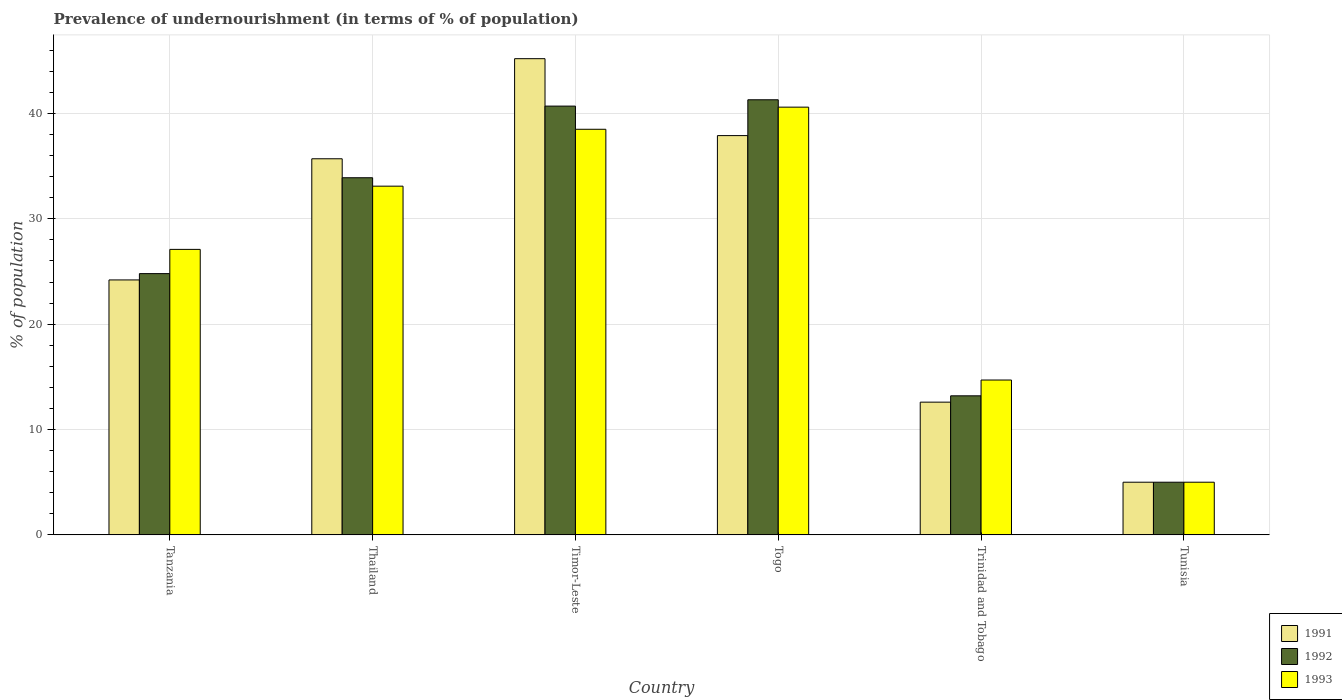How many groups of bars are there?
Make the answer very short. 6. What is the label of the 1st group of bars from the left?
Your response must be concise. Tanzania. What is the percentage of undernourished population in 1992 in Togo?
Offer a terse response. 41.3. Across all countries, what is the maximum percentage of undernourished population in 1993?
Your response must be concise. 40.6. Across all countries, what is the minimum percentage of undernourished population in 1991?
Provide a succinct answer. 5. In which country was the percentage of undernourished population in 1991 maximum?
Provide a succinct answer. Timor-Leste. In which country was the percentage of undernourished population in 1991 minimum?
Keep it short and to the point. Tunisia. What is the total percentage of undernourished population in 1993 in the graph?
Your answer should be compact. 159. What is the difference between the percentage of undernourished population in 1993 in Tanzania and that in Trinidad and Tobago?
Your response must be concise. 12.4. What is the average percentage of undernourished population in 1991 per country?
Keep it short and to the point. 26.77. In how many countries, is the percentage of undernourished population in 1991 greater than 38 %?
Make the answer very short. 1. What is the ratio of the percentage of undernourished population in 1991 in Thailand to that in Togo?
Your response must be concise. 0.94. Is the difference between the percentage of undernourished population in 1991 in Thailand and Togo greater than the difference between the percentage of undernourished population in 1992 in Thailand and Togo?
Offer a terse response. Yes. What is the difference between the highest and the lowest percentage of undernourished population in 1993?
Keep it short and to the point. 35.6. Is the sum of the percentage of undernourished population in 1992 in Tanzania and Thailand greater than the maximum percentage of undernourished population in 1991 across all countries?
Give a very brief answer. Yes. What does the 1st bar from the left in Tanzania represents?
Your answer should be compact. 1991. What does the 3rd bar from the right in Thailand represents?
Keep it short and to the point. 1991. Is it the case that in every country, the sum of the percentage of undernourished population in 1992 and percentage of undernourished population in 1991 is greater than the percentage of undernourished population in 1993?
Ensure brevity in your answer.  Yes. What is the difference between two consecutive major ticks on the Y-axis?
Provide a succinct answer. 10. Are the values on the major ticks of Y-axis written in scientific E-notation?
Your answer should be compact. No. Does the graph contain any zero values?
Offer a terse response. No. Where does the legend appear in the graph?
Your response must be concise. Bottom right. How many legend labels are there?
Keep it short and to the point. 3. How are the legend labels stacked?
Give a very brief answer. Vertical. What is the title of the graph?
Your answer should be compact. Prevalence of undernourishment (in terms of % of population). What is the label or title of the X-axis?
Your response must be concise. Country. What is the label or title of the Y-axis?
Your answer should be compact. % of population. What is the % of population in 1991 in Tanzania?
Ensure brevity in your answer.  24.2. What is the % of population in 1992 in Tanzania?
Ensure brevity in your answer.  24.8. What is the % of population of 1993 in Tanzania?
Provide a succinct answer. 27.1. What is the % of population of 1991 in Thailand?
Offer a terse response. 35.7. What is the % of population in 1992 in Thailand?
Provide a short and direct response. 33.9. What is the % of population in 1993 in Thailand?
Ensure brevity in your answer.  33.1. What is the % of population in 1991 in Timor-Leste?
Offer a terse response. 45.2. What is the % of population in 1992 in Timor-Leste?
Provide a short and direct response. 40.7. What is the % of population of 1993 in Timor-Leste?
Your answer should be very brief. 38.5. What is the % of population in 1991 in Togo?
Your answer should be very brief. 37.9. What is the % of population of 1992 in Togo?
Make the answer very short. 41.3. What is the % of population in 1993 in Togo?
Offer a terse response. 40.6. What is the % of population in 1993 in Trinidad and Tobago?
Offer a very short reply. 14.7. What is the % of population of 1993 in Tunisia?
Your response must be concise. 5. Across all countries, what is the maximum % of population in 1991?
Provide a succinct answer. 45.2. Across all countries, what is the maximum % of population in 1992?
Provide a succinct answer. 41.3. Across all countries, what is the maximum % of population of 1993?
Make the answer very short. 40.6. Across all countries, what is the minimum % of population in 1992?
Offer a very short reply. 5. What is the total % of population in 1991 in the graph?
Your answer should be compact. 160.6. What is the total % of population in 1992 in the graph?
Offer a terse response. 158.9. What is the total % of population in 1993 in the graph?
Your answer should be compact. 159. What is the difference between the % of population of 1991 in Tanzania and that in Thailand?
Your answer should be very brief. -11.5. What is the difference between the % of population of 1992 in Tanzania and that in Timor-Leste?
Provide a short and direct response. -15.9. What is the difference between the % of population of 1993 in Tanzania and that in Timor-Leste?
Give a very brief answer. -11.4. What is the difference between the % of population of 1991 in Tanzania and that in Togo?
Your answer should be compact. -13.7. What is the difference between the % of population in 1992 in Tanzania and that in Togo?
Your response must be concise. -16.5. What is the difference between the % of population in 1993 in Tanzania and that in Trinidad and Tobago?
Your response must be concise. 12.4. What is the difference between the % of population in 1991 in Tanzania and that in Tunisia?
Ensure brevity in your answer.  19.2. What is the difference between the % of population of 1992 in Tanzania and that in Tunisia?
Provide a succinct answer. 19.8. What is the difference between the % of population of 1993 in Tanzania and that in Tunisia?
Offer a very short reply. 22.1. What is the difference between the % of population of 1993 in Thailand and that in Timor-Leste?
Give a very brief answer. -5.4. What is the difference between the % of population of 1991 in Thailand and that in Togo?
Your response must be concise. -2.2. What is the difference between the % of population of 1991 in Thailand and that in Trinidad and Tobago?
Give a very brief answer. 23.1. What is the difference between the % of population in 1992 in Thailand and that in Trinidad and Tobago?
Provide a short and direct response. 20.7. What is the difference between the % of population of 1991 in Thailand and that in Tunisia?
Your answer should be very brief. 30.7. What is the difference between the % of population of 1992 in Thailand and that in Tunisia?
Keep it short and to the point. 28.9. What is the difference between the % of population in 1993 in Thailand and that in Tunisia?
Your answer should be very brief. 28.1. What is the difference between the % of population of 1991 in Timor-Leste and that in Togo?
Make the answer very short. 7.3. What is the difference between the % of population of 1992 in Timor-Leste and that in Togo?
Your answer should be very brief. -0.6. What is the difference between the % of population of 1993 in Timor-Leste and that in Togo?
Make the answer very short. -2.1. What is the difference between the % of population of 1991 in Timor-Leste and that in Trinidad and Tobago?
Ensure brevity in your answer.  32.6. What is the difference between the % of population in 1993 in Timor-Leste and that in Trinidad and Tobago?
Ensure brevity in your answer.  23.8. What is the difference between the % of population of 1991 in Timor-Leste and that in Tunisia?
Your response must be concise. 40.2. What is the difference between the % of population in 1992 in Timor-Leste and that in Tunisia?
Provide a short and direct response. 35.7. What is the difference between the % of population of 1993 in Timor-Leste and that in Tunisia?
Provide a succinct answer. 33.5. What is the difference between the % of population of 1991 in Togo and that in Trinidad and Tobago?
Your answer should be compact. 25.3. What is the difference between the % of population of 1992 in Togo and that in Trinidad and Tobago?
Give a very brief answer. 28.1. What is the difference between the % of population in 1993 in Togo and that in Trinidad and Tobago?
Your answer should be compact. 25.9. What is the difference between the % of population in 1991 in Togo and that in Tunisia?
Offer a terse response. 32.9. What is the difference between the % of population in 1992 in Togo and that in Tunisia?
Offer a terse response. 36.3. What is the difference between the % of population of 1993 in Togo and that in Tunisia?
Your response must be concise. 35.6. What is the difference between the % of population of 1991 in Trinidad and Tobago and that in Tunisia?
Your answer should be very brief. 7.6. What is the difference between the % of population of 1992 in Trinidad and Tobago and that in Tunisia?
Give a very brief answer. 8.2. What is the difference between the % of population of 1993 in Trinidad and Tobago and that in Tunisia?
Make the answer very short. 9.7. What is the difference between the % of population in 1991 in Tanzania and the % of population in 1992 in Timor-Leste?
Your response must be concise. -16.5. What is the difference between the % of population in 1991 in Tanzania and the % of population in 1993 in Timor-Leste?
Your response must be concise. -14.3. What is the difference between the % of population of 1992 in Tanzania and the % of population of 1993 in Timor-Leste?
Offer a very short reply. -13.7. What is the difference between the % of population of 1991 in Tanzania and the % of population of 1992 in Togo?
Make the answer very short. -17.1. What is the difference between the % of population in 1991 in Tanzania and the % of population in 1993 in Togo?
Give a very brief answer. -16.4. What is the difference between the % of population in 1992 in Tanzania and the % of population in 1993 in Togo?
Offer a terse response. -15.8. What is the difference between the % of population in 1991 in Tanzania and the % of population in 1992 in Trinidad and Tobago?
Offer a very short reply. 11. What is the difference between the % of population of 1992 in Tanzania and the % of population of 1993 in Trinidad and Tobago?
Your answer should be very brief. 10.1. What is the difference between the % of population in 1991 in Tanzania and the % of population in 1993 in Tunisia?
Make the answer very short. 19.2. What is the difference between the % of population in 1992 in Tanzania and the % of population in 1993 in Tunisia?
Your response must be concise. 19.8. What is the difference between the % of population in 1991 in Thailand and the % of population in 1992 in Timor-Leste?
Your response must be concise. -5. What is the difference between the % of population of 1991 in Thailand and the % of population of 1993 in Togo?
Provide a short and direct response. -4.9. What is the difference between the % of population of 1992 in Thailand and the % of population of 1993 in Togo?
Provide a succinct answer. -6.7. What is the difference between the % of population of 1991 in Thailand and the % of population of 1992 in Trinidad and Tobago?
Your answer should be compact. 22.5. What is the difference between the % of population of 1991 in Thailand and the % of population of 1993 in Trinidad and Tobago?
Provide a short and direct response. 21. What is the difference between the % of population of 1992 in Thailand and the % of population of 1993 in Trinidad and Tobago?
Make the answer very short. 19.2. What is the difference between the % of population in 1991 in Thailand and the % of population in 1992 in Tunisia?
Give a very brief answer. 30.7. What is the difference between the % of population of 1991 in Thailand and the % of population of 1993 in Tunisia?
Ensure brevity in your answer.  30.7. What is the difference between the % of population of 1992 in Thailand and the % of population of 1993 in Tunisia?
Give a very brief answer. 28.9. What is the difference between the % of population in 1991 in Timor-Leste and the % of population in 1992 in Togo?
Give a very brief answer. 3.9. What is the difference between the % of population of 1991 in Timor-Leste and the % of population of 1992 in Trinidad and Tobago?
Provide a short and direct response. 32. What is the difference between the % of population of 1991 in Timor-Leste and the % of population of 1993 in Trinidad and Tobago?
Your response must be concise. 30.5. What is the difference between the % of population in 1992 in Timor-Leste and the % of population in 1993 in Trinidad and Tobago?
Give a very brief answer. 26. What is the difference between the % of population in 1991 in Timor-Leste and the % of population in 1992 in Tunisia?
Your answer should be compact. 40.2. What is the difference between the % of population in 1991 in Timor-Leste and the % of population in 1993 in Tunisia?
Your answer should be compact. 40.2. What is the difference between the % of population in 1992 in Timor-Leste and the % of population in 1993 in Tunisia?
Provide a succinct answer. 35.7. What is the difference between the % of population of 1991 in Togo and the % of population of 1992 in Trinidad and Tobago?
Provide a succinct answer. 24.7. What is the difference between the % of population in 1991 in Togo and the % of population in 1993 in Trinidad and Tobago?
Provide a succinct answer. 23.2. What is the difference between the % of population in 1992 in Togo and the % of population in 1993 in Trinidad and Tobago?
Provide a succinct answer. 26.6. What is the difference between the % of population of 1991 in Togo and the % of population of 1992 in Tunisia?
Make the answer very short. 32.9. What is the difference between the % of population of 1991 in Togo and the % of population of 1993 in Tunisia?
Make the answer very short. 32.9. What is the difference between the % of population of 1992 in Togo and the % of population of 1993 in Tunisia?
Your answer should be compact. 36.3. What is the difference between the % of population of 1991 in Trinidad and Tobago and the % of population of 1992 in Tunisia?
Ensure brevity in your answer.  7.6. What is the difference between the % of population in 1992 in Trinidad and Tobago and the % of population in 1993 in Tunisia?
Your response must be concise. 8.2. What is the average % of population of 1991 per country?
Provide a succinct answer. 26.77. What is the average % of population in 1992 per country?
Offer a very short reply. 26.48. What is the difference between the % of population in 1991 and % of population in 1992 in Thailand?
Provide a succinct answer. 1.8. What is the difference between the % of population of 1992 and % of population of 1993 in Thailand?
Your response must be concise. 0.8. What is the difference between the % of population in 1991 and % of population in 1992 in Timor-Leste?
Give a very brief answer. 4.5. What is the difference between the % of population in 1991 and % of population in 1993 in Timor-Leste?
Provide a short and direct response. 6.7. What is the difference between the % of population in 1992 and % of population in 1993 in Timor-Leste?
Your response must be concise. 2.2. What is the difference between the % of population in 1991 and % of population in 1992 in Togo?
Your answer should be very brief. -3.4. What is the difference between the % of population in 1991 and % of population in 1993 in Togo?
Provide a short and direct response. -2.7. What is the difference between the % of population of 1992 and % of population of 1993 in Togo?
Provide a succinct answer. 0.7. What is the difference between the % of population in 1991 and % of population in 1992 in Tunisia?
Provide a short and direct response. 0. What is the ratio of the % of population in 1991 in Tanzania to that in Thailand?
Keep it short and to the point. 0.68. What is the ratio of the % of population of 1992 in Tanzania to that in Thailand?
Your response must be concise. 0.73. What is the ratio of the % of population of 1993 in Tanzania to that in Thailand?
Offer a very short reply. 0.82. What is the ratio of the % of population in 1991 in Tanzania to that in Timor-Leste?
Your answer should be compact. 0.54. What is the ratio of the % of population of 1992 in Tanzania to that in Timor-Leste?
Provide a succinct answer. 0.61. What is the ratio of the % of population of 1993 in Tanzania to that in Timor-Leste?
Offer a very short reply. 0.7. What is the ratio of the % of population in 1991 in Tanzania to that in Togo?
Make the answer very short. 0.64. What is the ratio of the % of population of 1992 in Tanzania to that in Togo?
Your answer should be compact. 0.6. What is the ratio of the % of population in 1993 in Tanzania to that in Togo?
Your answer should be very brief. 0.67. What is the ratio of the % of population in 1991 in Tanzania to that in Trinidad and Tobago?
Provide a succinct answer. 1.92. What is the ratio of the % of population in 1992 in Tanzania to that in Trinidad and Tobago?
Your answer should be very brief. 1.88. What is the ratio of the % of population in 1993 in Tanzania to that in Trinidad and Tobago?
Your answer should be very brief. 1.84. What is the ratio of the % of population of 1991 in Tanzania to that in Tunisia?
Your answer should be very brief. 4.84. What is the ratio of the % of population in 1992 in Tanzania to that in Tunisia?
Keep it short and to the point. 4.96. What is the ratio of the % of population of 1993 in Tanzania to that in Tunisia?
Keep it short and to the point. 5.42. What is the ratio of the % of population of 1991 in Thailand to that in Timor-Leste?
Provide a short and direct response. 0.79. What is the ratio of the % of population in 1992 in Thailand to that in Timor-Leste?
Provide a short and direct response. 0.83. What is the ratio of the % of population in 1993 in Thailand to that in Timor-Leste?
Keep it short and to the point. 0.86. What is the ratio of the % of population of 1991 in Thailand to that in Togo?
Provide a short and direct response. 0.94. What is the ratio of the % of population of 1992 in Thailand to that in Togo?
Offer a very short reply. 0.82. What is the ratio of the % of population of 1993 in Thailand to that in Togo?
Give a very brief answer. 0.82. What is the ratio of the % of population in 1991 in Thailand to that in Trinidad and Tobago?
Keep it short and to the point. 2.83. What is the ratio of the % of population of 1992 in Thailand to that in Trinidad and Tobago?
Keep it short and to the point. 2.57. What is the ratio of the % of population of 1993 in Thailand to that in Trinidad and Tobago?
Offer a very short reply. 2.25. What is the ratio of the % of population in 1991 in Thailand to that in Tunisia?
Offer a terse response. 7.14. What is the ratio of the % of population in 1992 in Thailand to that in Tunisia?
Your answer should be very brief. 6.78. What is the ratio of the % of population of 1993 in Thailand to that in Tunisia?
Provide a short and direct response. 6.62. What is the ratio of the % of population of 1991 in Timor-Leste to that in Togo?
Your response must be concise. 1.19. What is the ratio of the % of population in 1992 in Timor-Leste to that in Togo?
Your answer should be compact. 0.99. What is the ratio of the % of population in 1993 in Timor-Leste to that in Togo?
Keep it short and to the point. 0.95. What is the ratio of the % of population in 1991 in Timor-Leste to that in Trinidad and Tobago?
Provide a short and direct response. 3.59. What is the ratio of the % of population of 1992 in Timor-Leste to that in Trinidad and Tobago?
Ensure brevity in your answer.  3.08. What is the ratio of the % of population in 1993 in Timor-Leste to that in Trinidad and Tobago?
Keep it short and to the point. 2.62. What is the ratio of the % of population in 1991 in Timor-Leste to that in Tunisia?
Offer a terse response. 9.04. What is the ratio of the % of population of 1992 in Timor-Leste to that in Tunisia?
Your response must be concise. 8.14. What is the ratio of the % of population of 1993 in Timor-Leste to that in Tunisia?
Give a very brief answer. 7.7. What is the ratio of the % of population of 1991 in Togo to that in Trinidad and Tobago?
Make the answer very short. 3.01. What is the ratio of the % of population of 1992 in Togo to that in Trinidad and Tobago?
Your answer should be compact. 3.13. What is the ratio of the % of population of 1993 in Togo to that in Trinidad and Tobago?
Make the answer very short. 2.76. What is the ratio of the % of population of 1991 in Togo to that in Tunisia?
Your answer should be very brief. 7.58. What is the ratio of the % of population of 1992 in Togo to that in Tunisia?
Offer a very short reply. 8.26. What is the ratio of the % of population of 1993 in Togo to that in Tunisia?
Provide a succinct answer. 8.12. What is the ratio of the % of population in 1991 in Trinidad and Tobago to that in Tunisia?
Give a very brief answer. 2.52. What is the ratio of the % of population in 1992 in Trinidad and Tobago to that in Tunisia?
Offer a terse response. 2.64. What is the ratio of the % of population of 1993 in Trinidad and Tobago to that in Tunisia?
Offer a terse response. 2.94. What is the difference between the highest and the second highest % of population in 1991?
Offer a very short reply. 7.3. What is the difference between the highest and the second highest % of population of 1992?
Provide a succinct answer. 0.6. What is the difference between the highest and the second highest % of population of 1993?
Keep it short and to the point. 2.1. What is the difference between the highest and the lowest % of population in 1991?
Offer a terse response. 40.2. What is the difference between the highest and the lowest % of population in 1992?
Give a very brief answer. 36.3. What is the difference between the highest and the lowest % of population in 1993?
Offer a very short reply. 35.6. 